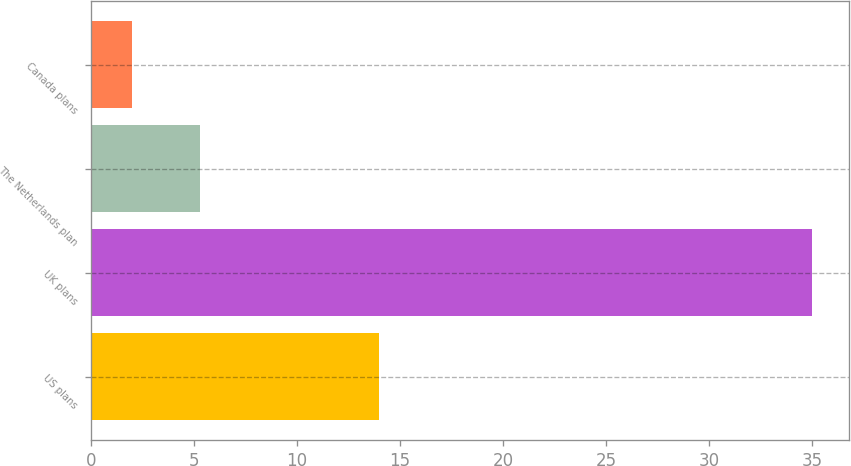Convert chart. <chart><loc_0><loc_0><loc_500><loc_500><bar_chart><fcel>US plans<fcel>UK plans<fcel>The Netherlands plan<fcel>Canada plans<nl><fcel>14<fcel>35<fcel>5.3<fcel>2<nl></chart> 